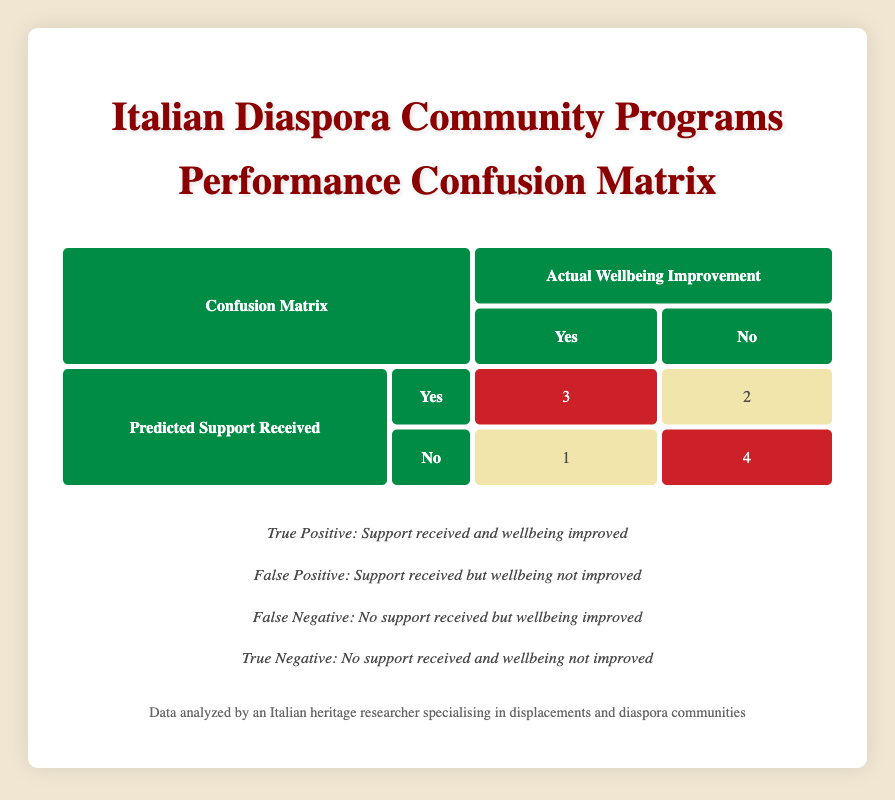What is the total number of programs that received support? By reviewing the table, we count the number of programs where "Support Received" is marked as "Yes". There are three such programs: Italian Cultural Association, Italian Heritage Festivals, and Italian Diaspora Support Network.
Answer: 5 How many programs had their well-being improved without receiving support? The table indicates "No" for support received but "Yes" for well-being improvement in one instance: the Art and Performance Nights program.
Answer: 1 What is the total count of programs that received support but did not improve well-being? We look at the programs with "Support Received" as "Yes" and "Well-being Improved" as "No". This applies to the Italian Language Classes and Youth Engagement Programs, making it two programs.
Answer: 2 What percentage of programs that received support saw improved well-being? To calculate this percentage, observe that there are five programs with support. Out of these, three programs indicated improvement. The percentage is (3/5) * 100 = 60%.
Answer: 60% Are there more programs that received support or those that did not? Counting the programs, we find five received support ("Yes") while the other five did not ("No"). They are equal in number.
Answer: No Which program is a true positive according to the confusion matrix? A true positive is defined as a program where support received leads to well-being improvement. Looking at the matrix, three programs qualify: Italian Cultural Association, Italian Heritage Festivals, and Italian Diaspora Support Network.
Answer: Italian Cultural Association, Italian Heritage Festivals, Italian Diaspora Support Network What is the ratio of false positives to true negatives in the matrix? There are two false positives (programs that received support but did not improve well-being) and four true negatives (programs that did not receive support and did not improve well-being). The ratio is 2:4, which simplifies to 1:2.
Answer: 1:2 How many programs were classified as true negatives? Reviewing the confusion matrix, true negatives are programs that did not receive support and did not show improved well-being. There are four such programs, namely the Italian Cooking Workshops, Health and Wellness Workshops, and Community Service Projects.
Answer: 4 What is the difference in the number of programs that improved well-being and those that did not improve well-being despite receiving support? From the matrix, three programs improved well-being (true positives) and two did not (false positives). The difference is 3 - 2 = 1 program.
Answer: 1 